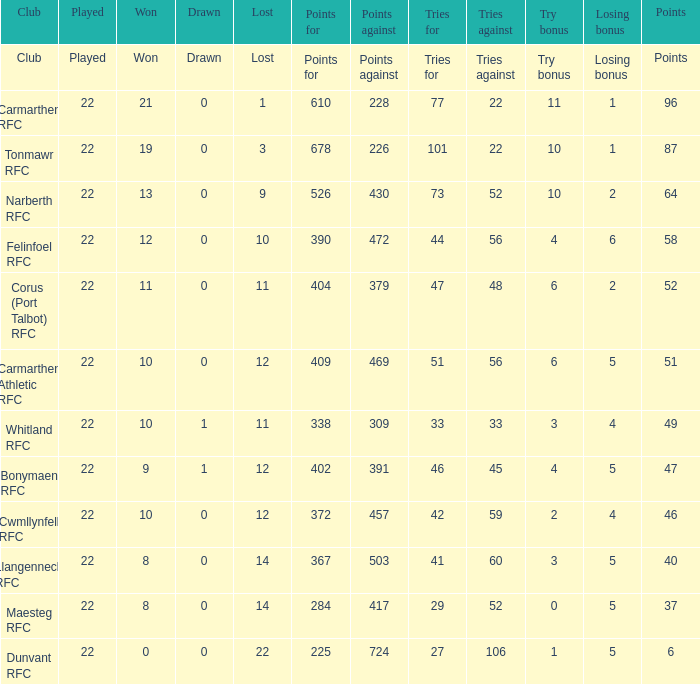Name the losing bonus for 27 5.0. 